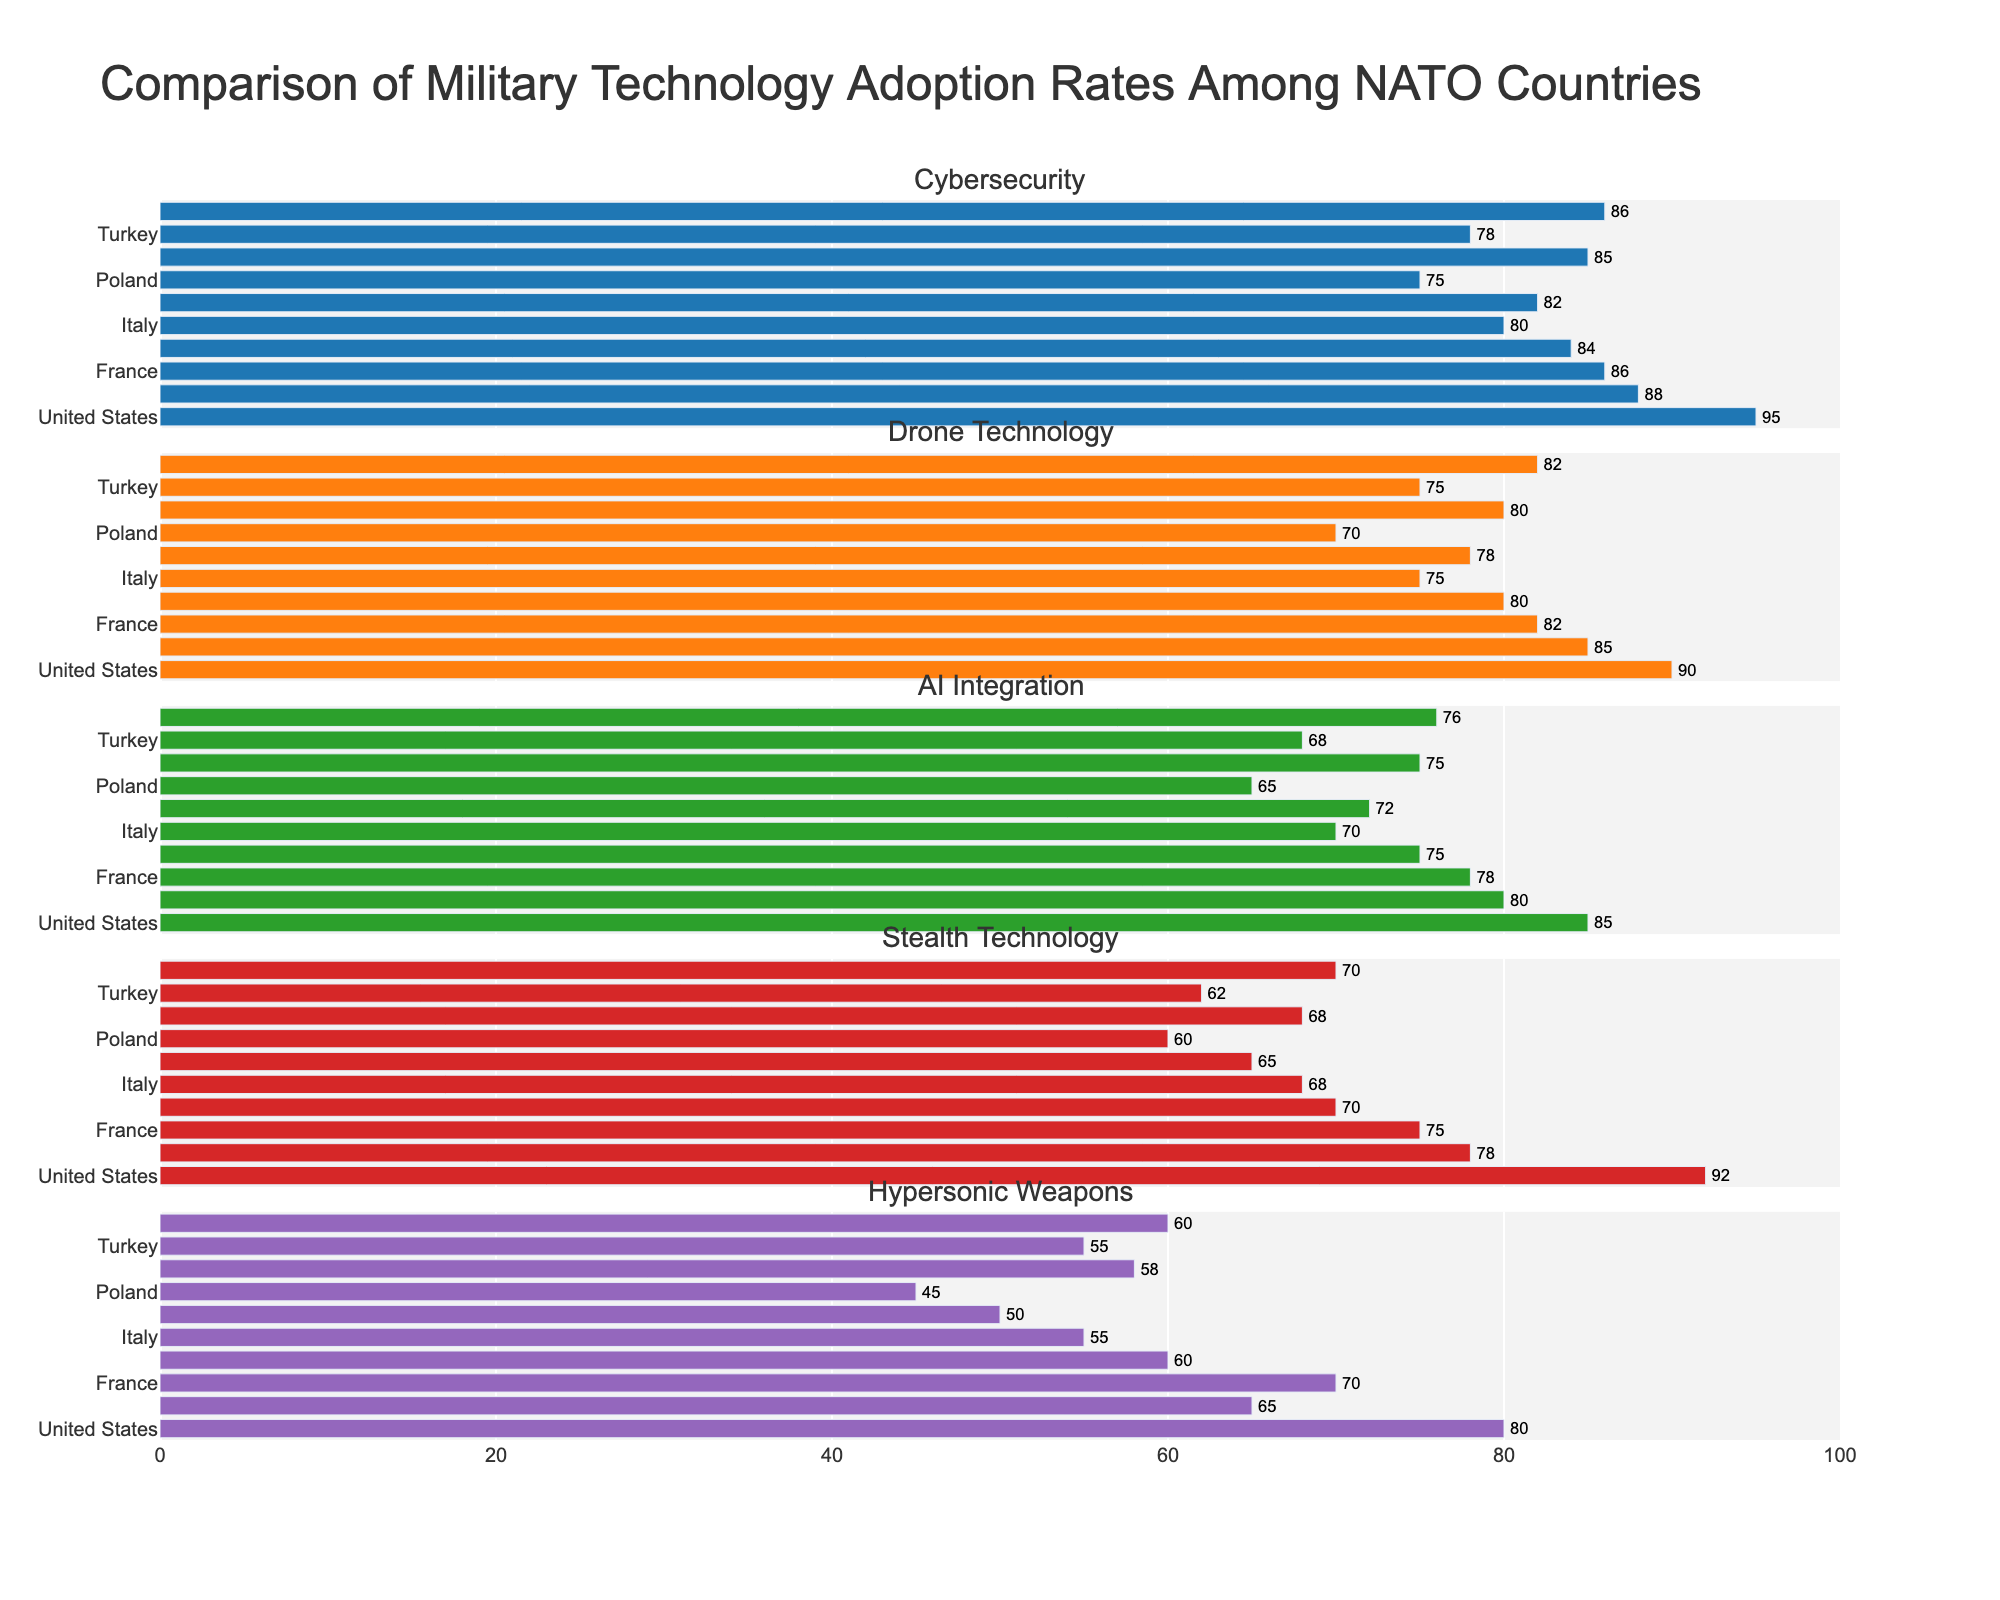How many manufacturing processes have their cycle times displayed in the bar plot? Count the number of bars in the bar plot, each representing a manufacturing process. There are 15 distinct bars.
Answer: 15 Which manufacturing process has the longest cycle time, and what is that time? Observe the height of the bars in the bar plot. The tallest bar corresponds to 3D Printing with a cycle time of 6.7 hours.
Answer: 3D Printing, 6.7 hours What is the cumulative percentage of cycle times achieved after the first four processes in the cumulative distribution plot? Identify the first four data points in the cumulative distribution. The processes are 3D Printing, Heat Treatment, Forging, and Assembly Line. The cumulative percentages are 16.9%, 33.1%, 46.8%, and 57.1% respectively. Therefore, after the first four processes, 57.1% of the cycle time has been accumulated.
Answer: 57.1% What is the median cycle time of the displayed manufacturing processes? To find the median, list the cycle times in ascending order and find the middle value. The sorted times are 1.1, 1.2, 1.5, 1.8, 2.3, 2.5, 2.7, 2.9, 3.1, 3.4, 3.9, 4.2, 4.8, 5.6, 6.7. The middle value (median) is the 8th value: 2.9 hours.
Answer: 2.9 hours Which manufacturing process contributes to the largest jump in the cumulative distribution plot? Look for the largest vertical gap between consecutive data points in the cumulative distribution line plot. The largest jump occurs between "Quality Control" and "Sheet Metal Forming". "Sheet Metal Forming" jumped by about 10.7%, which is the largest single increase.
Answer: Sheet Metal Forming How does the cycle time of Welding compare to that of CNC Machining? Identify the heights of the bars for Welding and CNC Machining in the bar plot. Welding has a cycle time of 3.1 hours, and CNC Machining has a cycle time of 2.5 hours. Therefore, Welding has a longer cycle time than CNC Machining.
Answer: Welding is higher What percentage of the total cycle time is contributed by the processes with the three shortest cycle times? Identify the three shortest cycle times (1.1, 1.2, 1.5 hours). Calculate their sum (1.1 + 1.2 + 1.5 = 3.8 hours), then divide by the total cycle time (sum of all cycle times) and multiply by 100 to find the percentage. The total cycle time is 46.8 hours, thus (3.8 / 46.8) * 100 = 8.1%.
Answer: 8.1% Does the "Quality Control" process fall in the first half or the second half of cycle times listed in ascending order? List the cycle times in ascending order: 1.1, 1.2, 1.5, 1.8, 2.3, 2.5, 2.7, 2.9, 3.1, 3.4, 3.9, 4.2, 4.8, 5.6, 6.7. "Quality Control" with a cycle time of 1.5 hours falls in the first half of the sorted list.
Answer: First half 